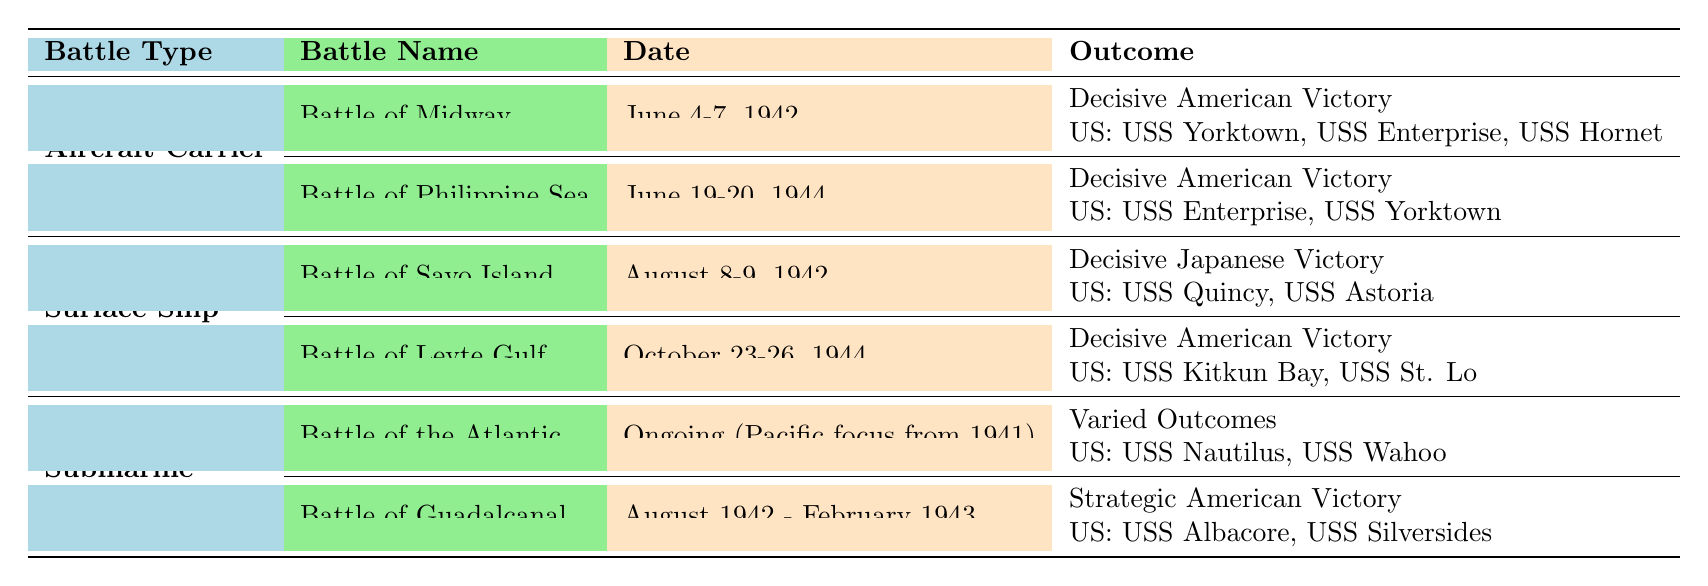What is the date of the Battle of Midway? The table lists the date for the Battle of Midway as June 4-7, 1942.
Answer: June 4-7, 1942 Which battle is categorized under Surface Ship Battles? The table shows two battles categorized under Surface Ship Battles: the Battle of Savo Island and the Battle of Leyte Gulf.
Answer: Battle of Savo Island, Battle of Leyte Gulf Did the United States achieve a decisive victory in the Battle of Leyte Gulf? From the table, it indicates that the outcome of the Battle of Leyte Gulf is a Decisive American Victory. Thus, the answer is true.
Answer: Yes What key forces did the Americans deploy in the Battle of Guadalcanal? According to the table, the American key forces in the Battle of Guadalcanal were USS Albacore and USS Silversides.
Answer: USS Albacore, USS Silversides How many battles resulted in a decisive victory for the United States? The American victories listed in the table are found in the Battle of Midway, Battle of Philippine Sea, and Battle of Leyte Gulf, making a total of three such battles.
Answer: 3 Is the Battle of the Atlantic solely focused on the Pacific theater? The table indicates that the Battle of the Atlantic has a Pacific focus starting from 1941, which supports that it is not solely focused on this area, thus the answer is false.
Answer: No Which battle occurred first: the Battle of Savo Island or the Battle of Midway? The Battle of Savo Island occurred on August 8-9, 1942, while the Battle of Midway occurred on June 4-7, 1942. Therefore, the Battle of Midway took place earlier.
Answer: Battle of Midway What was the outcome of the submarine battle involved in the Battle of Guadalcanal? The table specifies that the outcome of the Battle of Guadalcanal was a Strategic American Victory.
Answer: Strategic American Victory Which battle had the most number of key forces listed for the American side? The Battle of Midway and the Battle of Leyte Gulf both list three American key forces, while the others list two. Hence, these two battles have the most key forces listed.
Answer: Battle of Midway, Battle of Leyte Gulf 